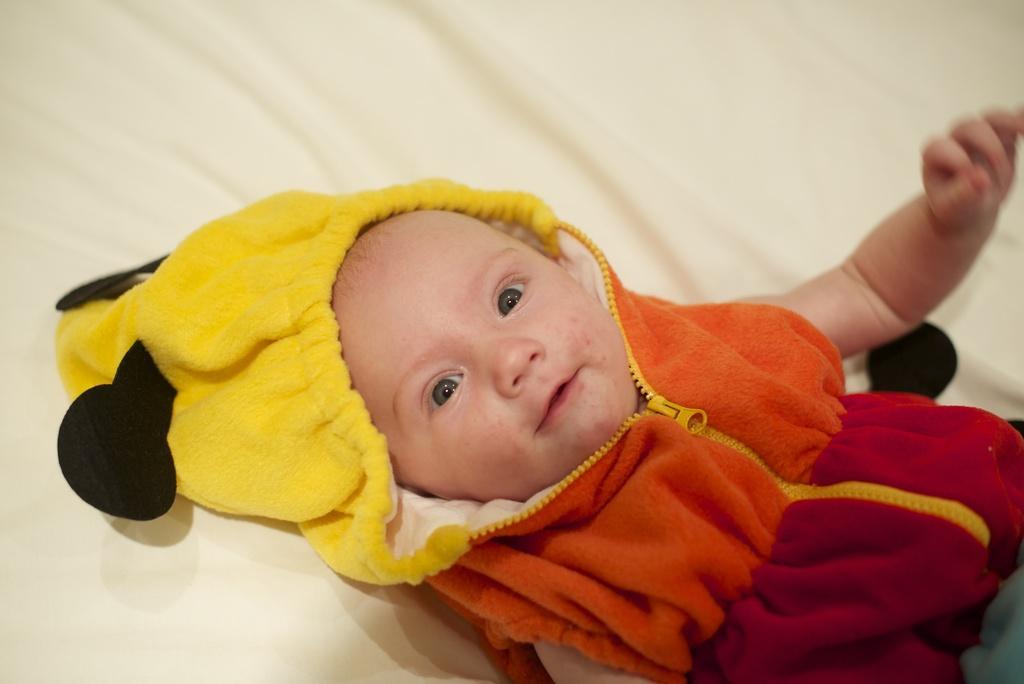Please provide a concise description of this image. In this picture I can observe a baby laying on the bed. The baby is wearing yellow, black, red and orange color hoodie. The background is in white color. 